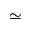<formula> <loc_0><loc_0><loc_500><loc_500>\simeq</formula> 